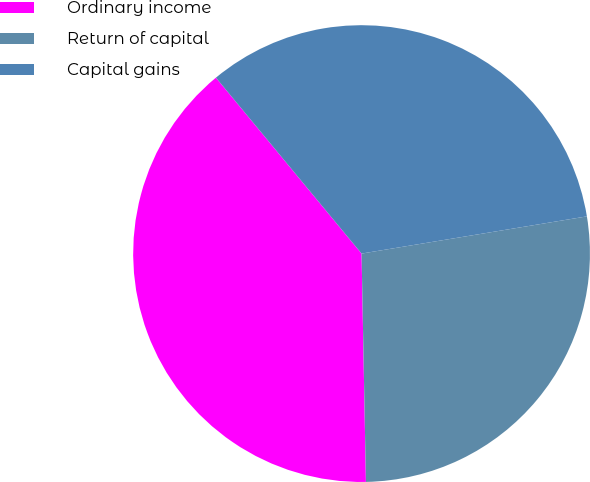Convert chart to OTSL. <chart><loc_0><loc_0><loc_500><loc_500><pie_chart><fcel>Ordinary income<fcel>Return of capital<fcel>Capital gains<nl><fcel>39.3%<fcel>27.3%<fcel>33.4%<nl></chart> 